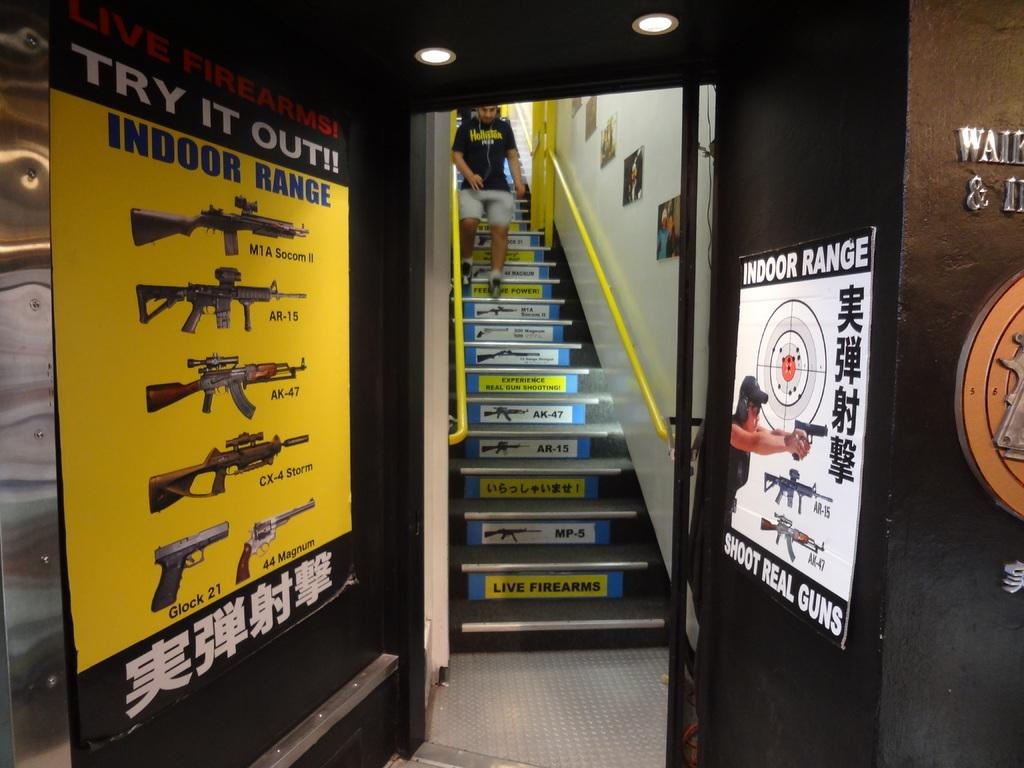Provide a one-sentence caption for the provided image. A open door leading to a stairway with signs on both sides of the doorway advertising an indoor range. 